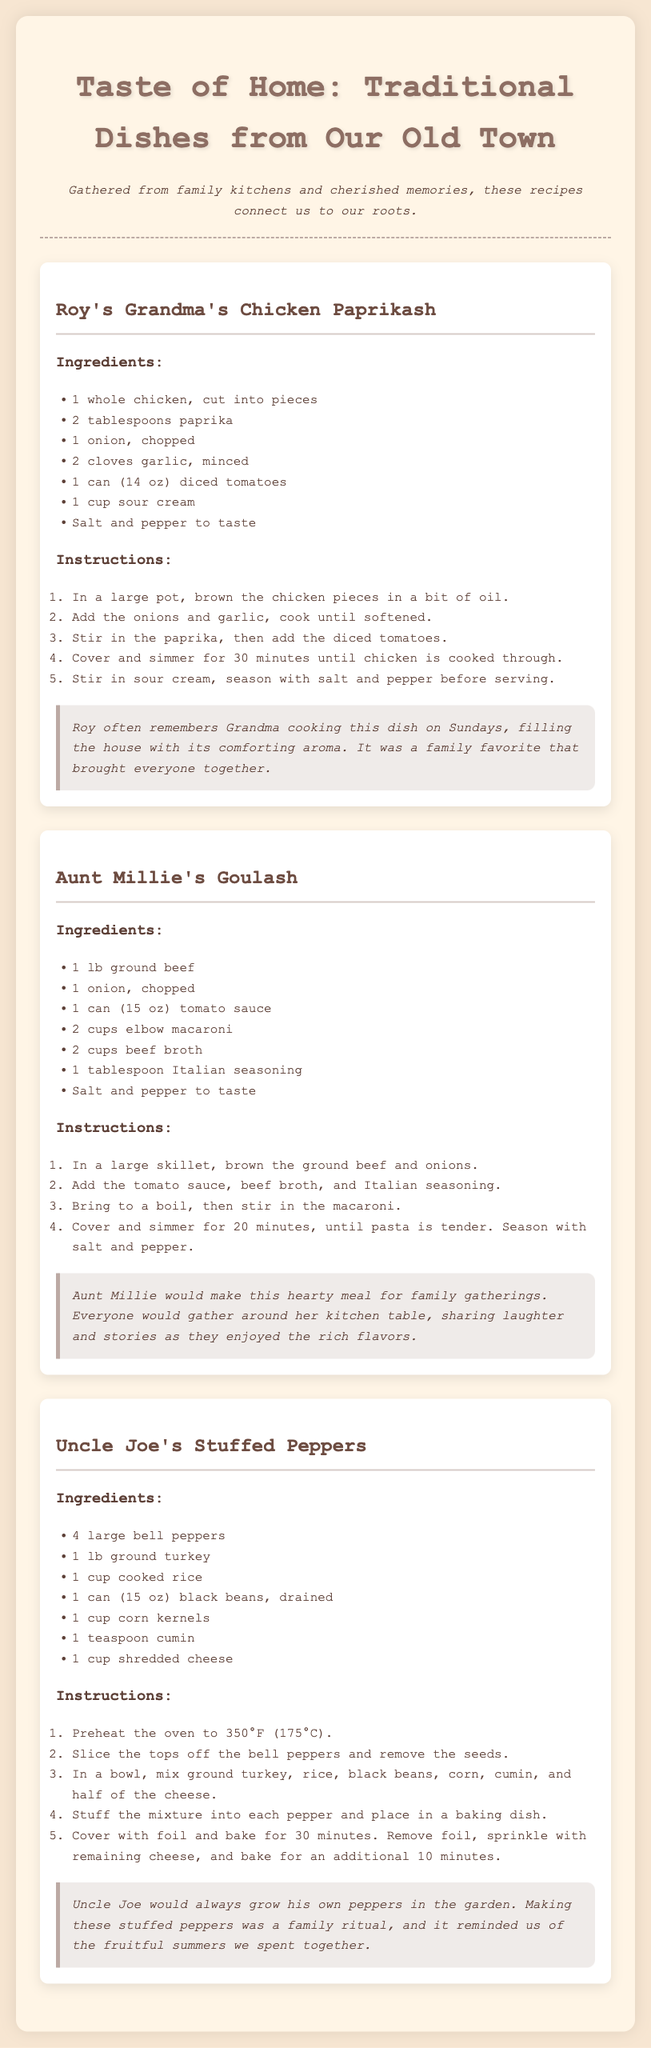What is the title of the recipe booklet? The title of the recipe booklet is presented prominently at the top of the document.
Answer: Taste of Home: Traditional Dishes from Our Old Town Who is the author of the Chicken Paprikash recipe? The author of the Chicken Paprikash recipe is noted in the recipe section.
Answer: Roy's Grandma How many ingredients are listed for Aunt Millie's Goulash? The number of ingredients can be counted in the recipe section for Aunt Millie's Goulash.
Answer: 7 What cooking method is used for Uncle Joe's Stuffed Peppers? The cooking method can be inferred from the instructions provided in the recipe.
Answer: Baking What was a common experience associated with Grandma's Chicken Paprikash? The story accompanying the recipe highlights a shared experience.
Answer: Family favorite What was Aunt Millie's Goulash made for? The context in which Aunt Millie's Goulash was prepared is described in the story section.
Answer: Family gatherings What ingredient is in all the main recipes? Analyzing the ingredients across the recipes indicates a common component.
Answer: Ground meat What type of cheese is used in Uncle Joe's Stuffed Peppers? The specific cheese used is stated in the ingredient list.
Answer: Shredded cheese 